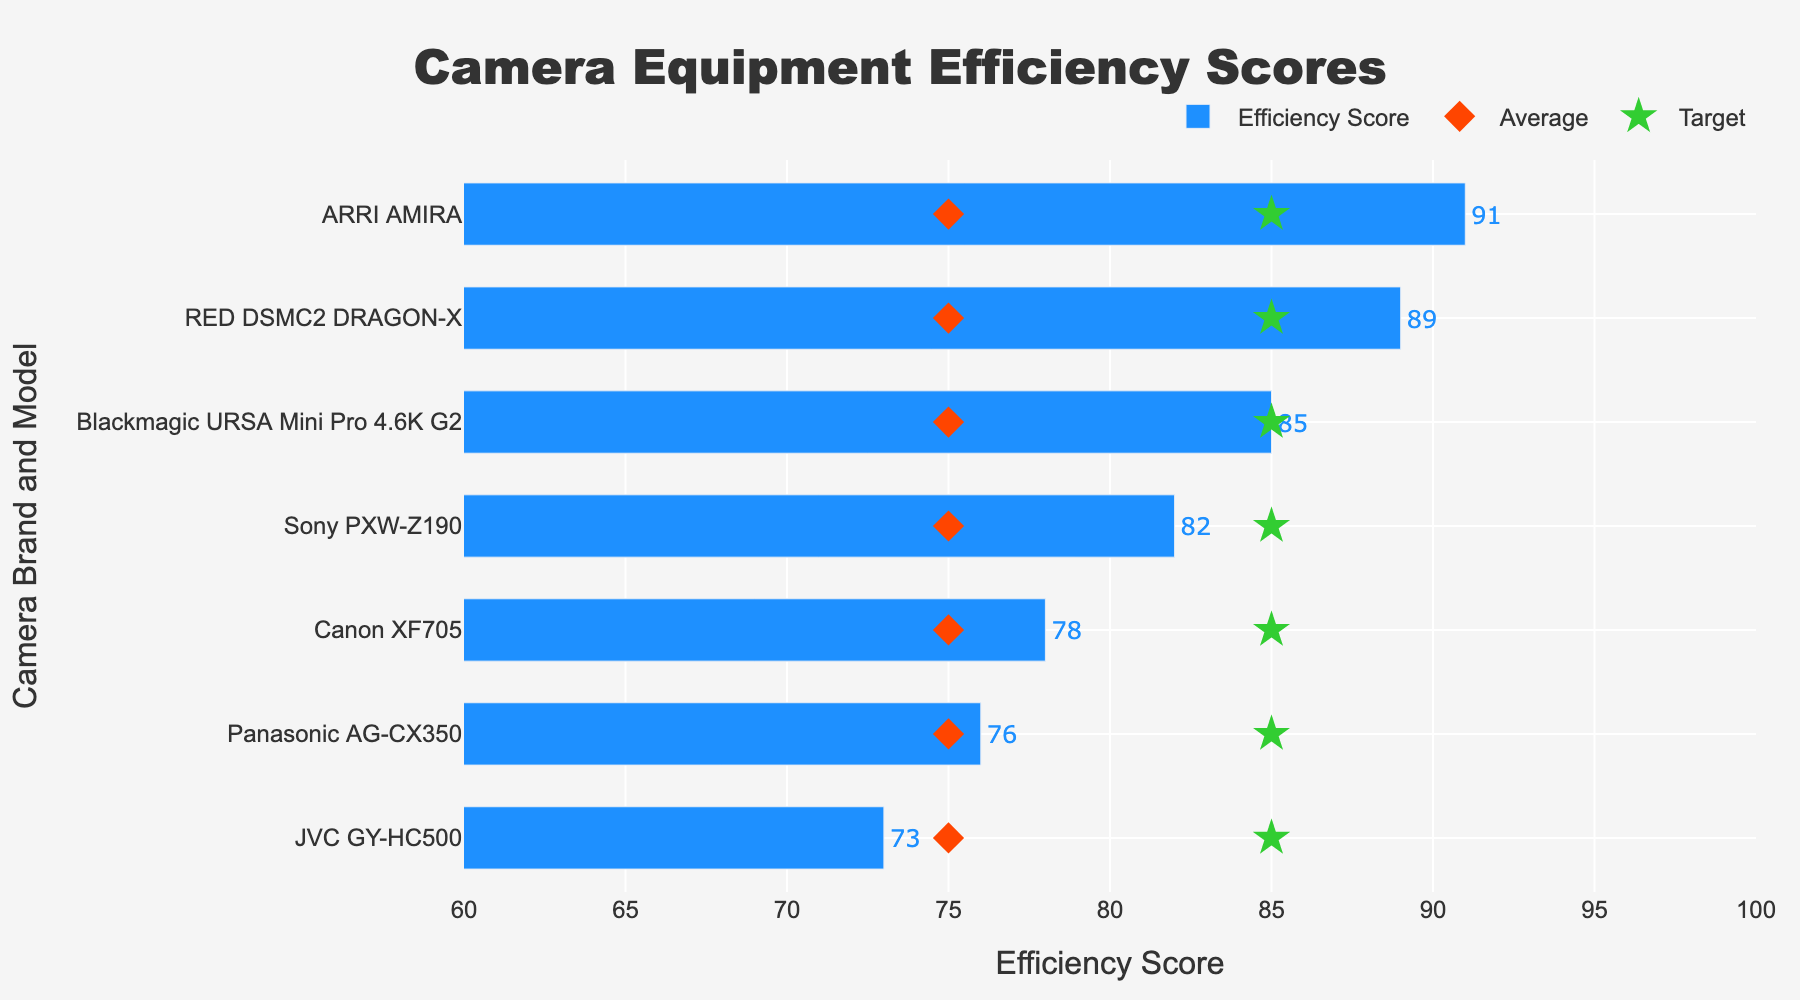What's the highest Efficiency Score among the camera models? The Efficiency Scores are listed next to each camera model. The highest score is associated with the ARRI AMIRA, which has a score of 91.
Answer: 91 Which camera model has the lowest Efficiency Score? The Efficiency Scores are sorted in ascending order in the figure. The JVC GY-HC500 has the lowest Efficiency Score of 73.
Answer: JVC GY-HC500 How many camera models have an Efficiency Score above the Target score? The Target score is 85. Models above this score are Blackmagic URSA Mini Pro 4.6K G2 (85), RED DSMC2 DRAGON-X (89), and ARRI AMIRA (91), including 3 models.
Answer: 3 Which brand and model are exactly at the Average score? The Average score is 75. No camera models have an Efficiency Score exactly at 75.
Answer: None What's the difference between the highest and the lowest Efficiency Scores? The highest score is 91 (ARRI AMIRA) and the lowest score is 73 (JVC GY-HC500). The difference is 91 - 73 = 18.
Answer: 18 How close is the Efficiency Score of the Canon XF705 to the Target score? The Efficiency Score of the Canon XF705 is 78, and the Target score is 85. The difference is 85 - 78 = 7.
Answer: 7 Which camera model exceeds the Target efficiency score by the largest margin? The ARRI AMIRA has an Efficiency Score of 91 and the Target score is 85. The margin is 91 - 85 = 6, which is the largest among the models.
Answer: ARRI AMIRA What's the average Efficiency Score of all camera models listed? Sum all Efficiency Scores: 82 + 78 + 76 + 73 + 85 + 89 + 91 = 574. There are 7 models. The average score is 574 / 7 ≈ 82.
Answer: 82 Which brands have multiple models in the list? Each brand appears only once in the list; no brands have multiple models listed.
Answer: None 